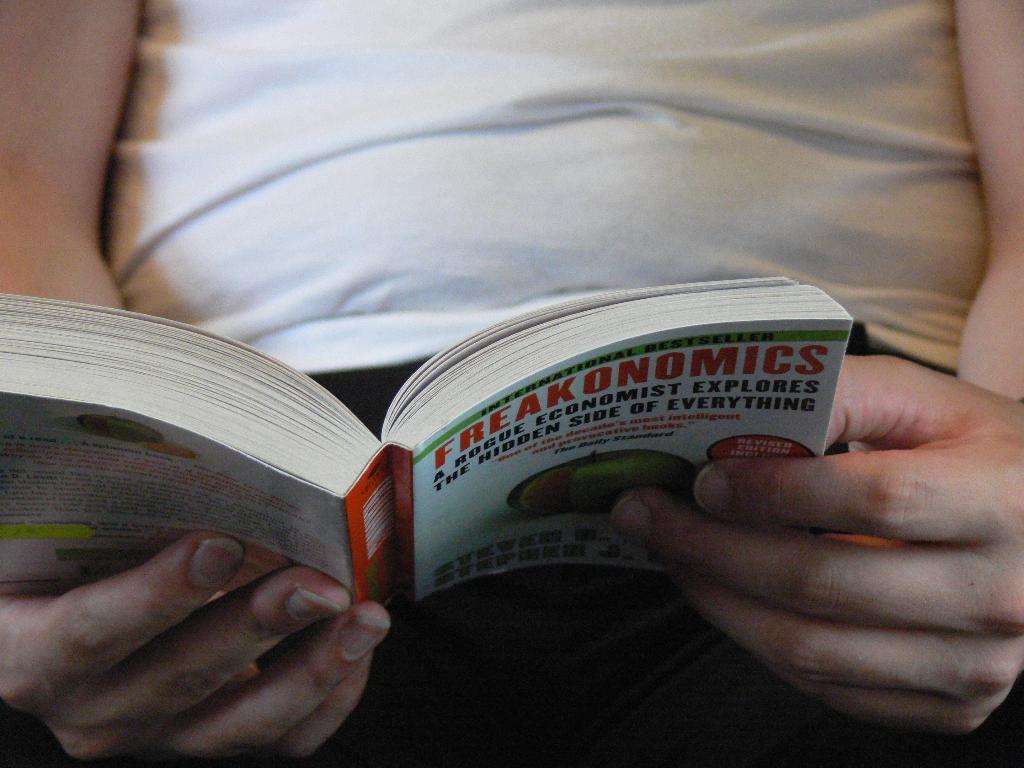Provide a one-sentence caption for the provided image. Man wearing a white shirt reading a book named Freakonomics. 